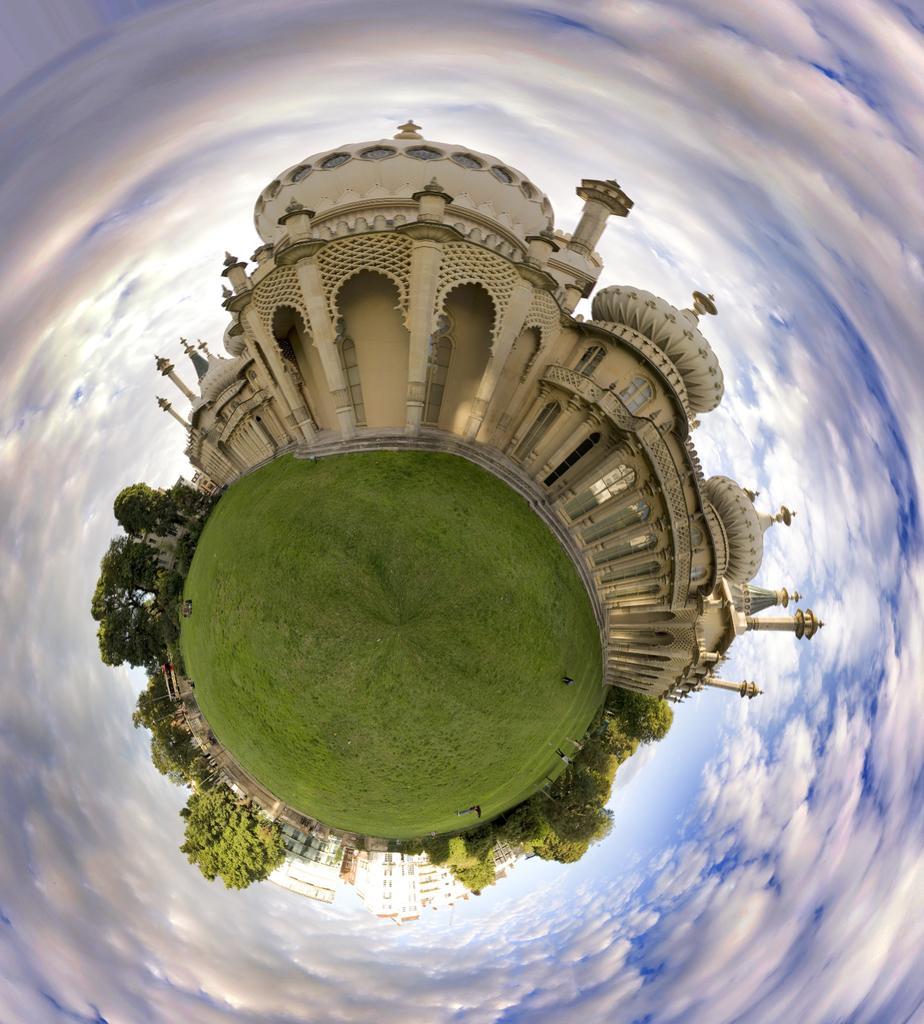In one or two sentences, can you explain what this image depicts? In the picture we can see the visual art image. There are buildings, trees and grass. We can see there are even people wearing clothes and the cloudy blue sky. 